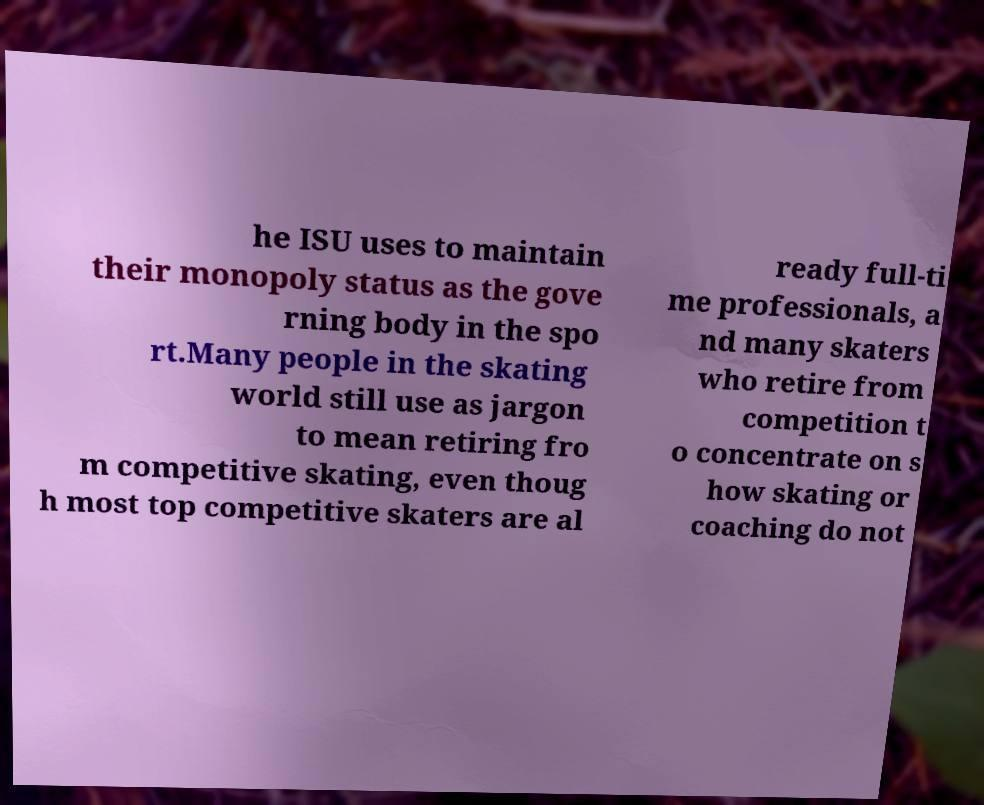Please read and relay the text visible in this image. What does it say? he ISU uses to maintain their monopoly status as the gove rning body in the spo rt.Many people in the skating world still use as jargon to mean retiring fro m competitive skating, even thoug h most top competitive skaters are al ready full-ti me professionals, a nd many skaters who retire from competition t o concentrate on s how skating or coaching do not 